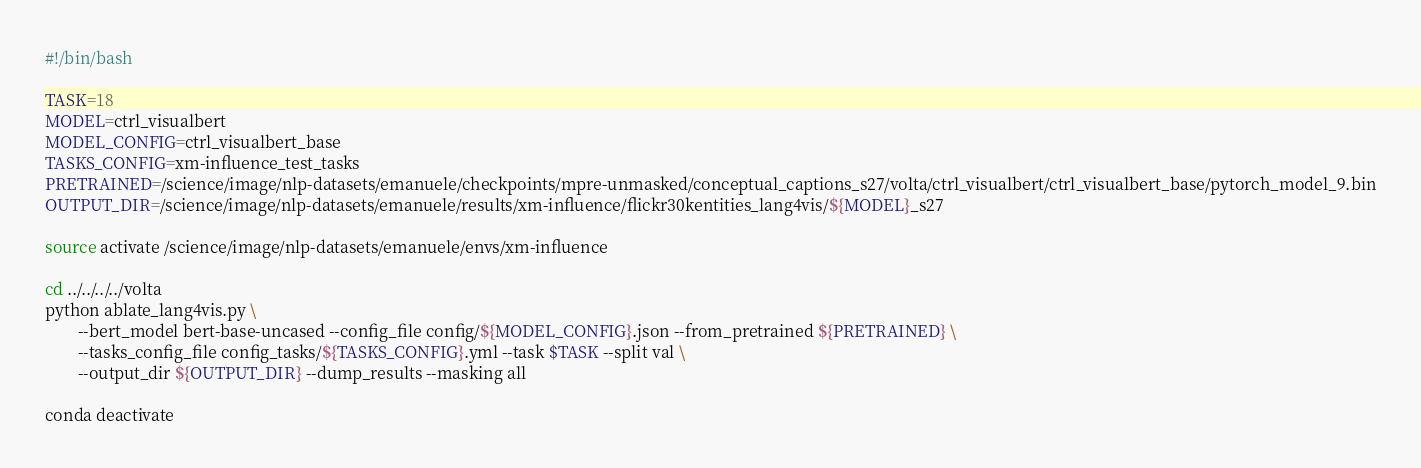Convert code to text. <code><loc_0><loc_0><loc_500><loc_500><_Bash_>#!/bin/bash

TASK=18
MODEL=ctrl_visualbert
MODEL_CONFIG=ctrl_visualbert_base
TASKS_CONFIG=xm-influence_test_tasks
PRETRAINED=/science/image/nlp-datasets/emanuele/checkpoints/mpre-unmasked/conceptual_captions_s27/volta/ctrl_visualbert/ctrl_visualbert_base/pytorch_model_9.bin
OUTPUT_DIR=/science/image/nlp-datasets/emanuele/results/xm-influence/flickr30kentities_lang4vis/${MODEL}_s27

source activate /science/image/nlp-datasets/emanuele/envs/xm-influence

cd ../../../../volta
python ablate_lang4vis.py \
        --bert_model bert-base-uncased --config_file config/${MODEL_CONFIG}.json --from_pretrained ${PRETRAINED} \
        --tasks_config_file config_tasks/${TASKS_CONFIG}.yml --task $TASK --split val \
        --output_dir ${OUTPUT_DIR} --dump_results --masking all

conda deactivate
</code> 